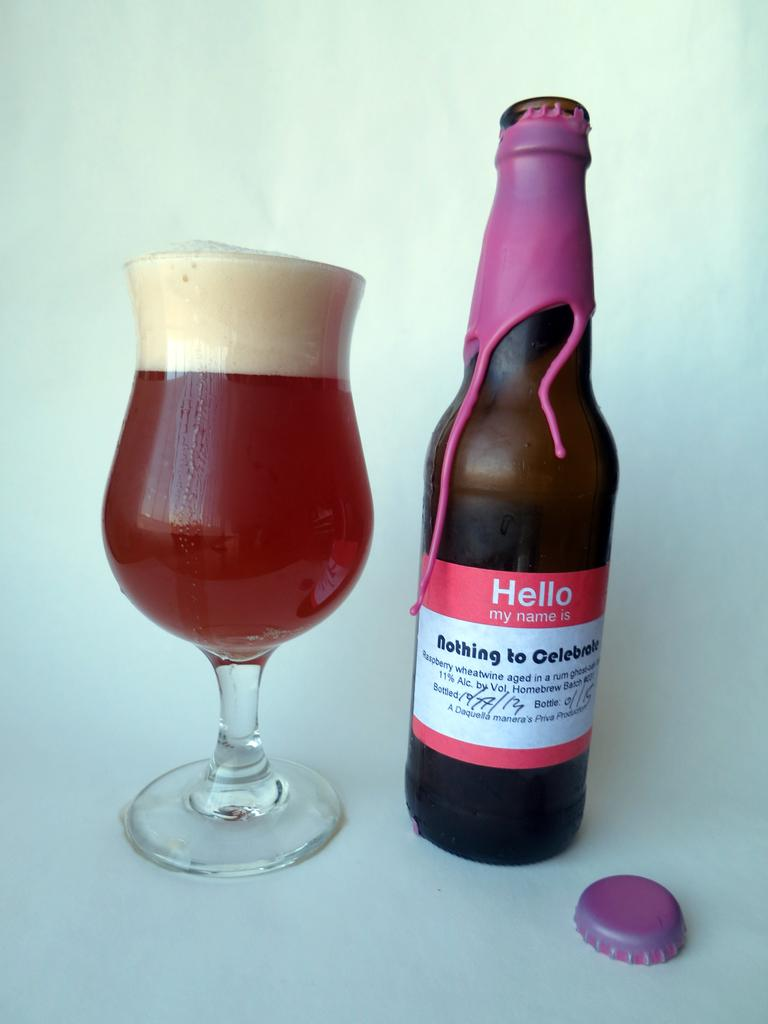What is contained in the glass that is visible in the image? There is a drink in the glass in the image. What other beverage-related item can be seen in the image? There is a bottle in the image. What part of the bottle is visible in the image? There is a bottle cap in the image. How does the paper contribute to the wealth of the person in the image? There is no paper or indication of wealth in the image. 